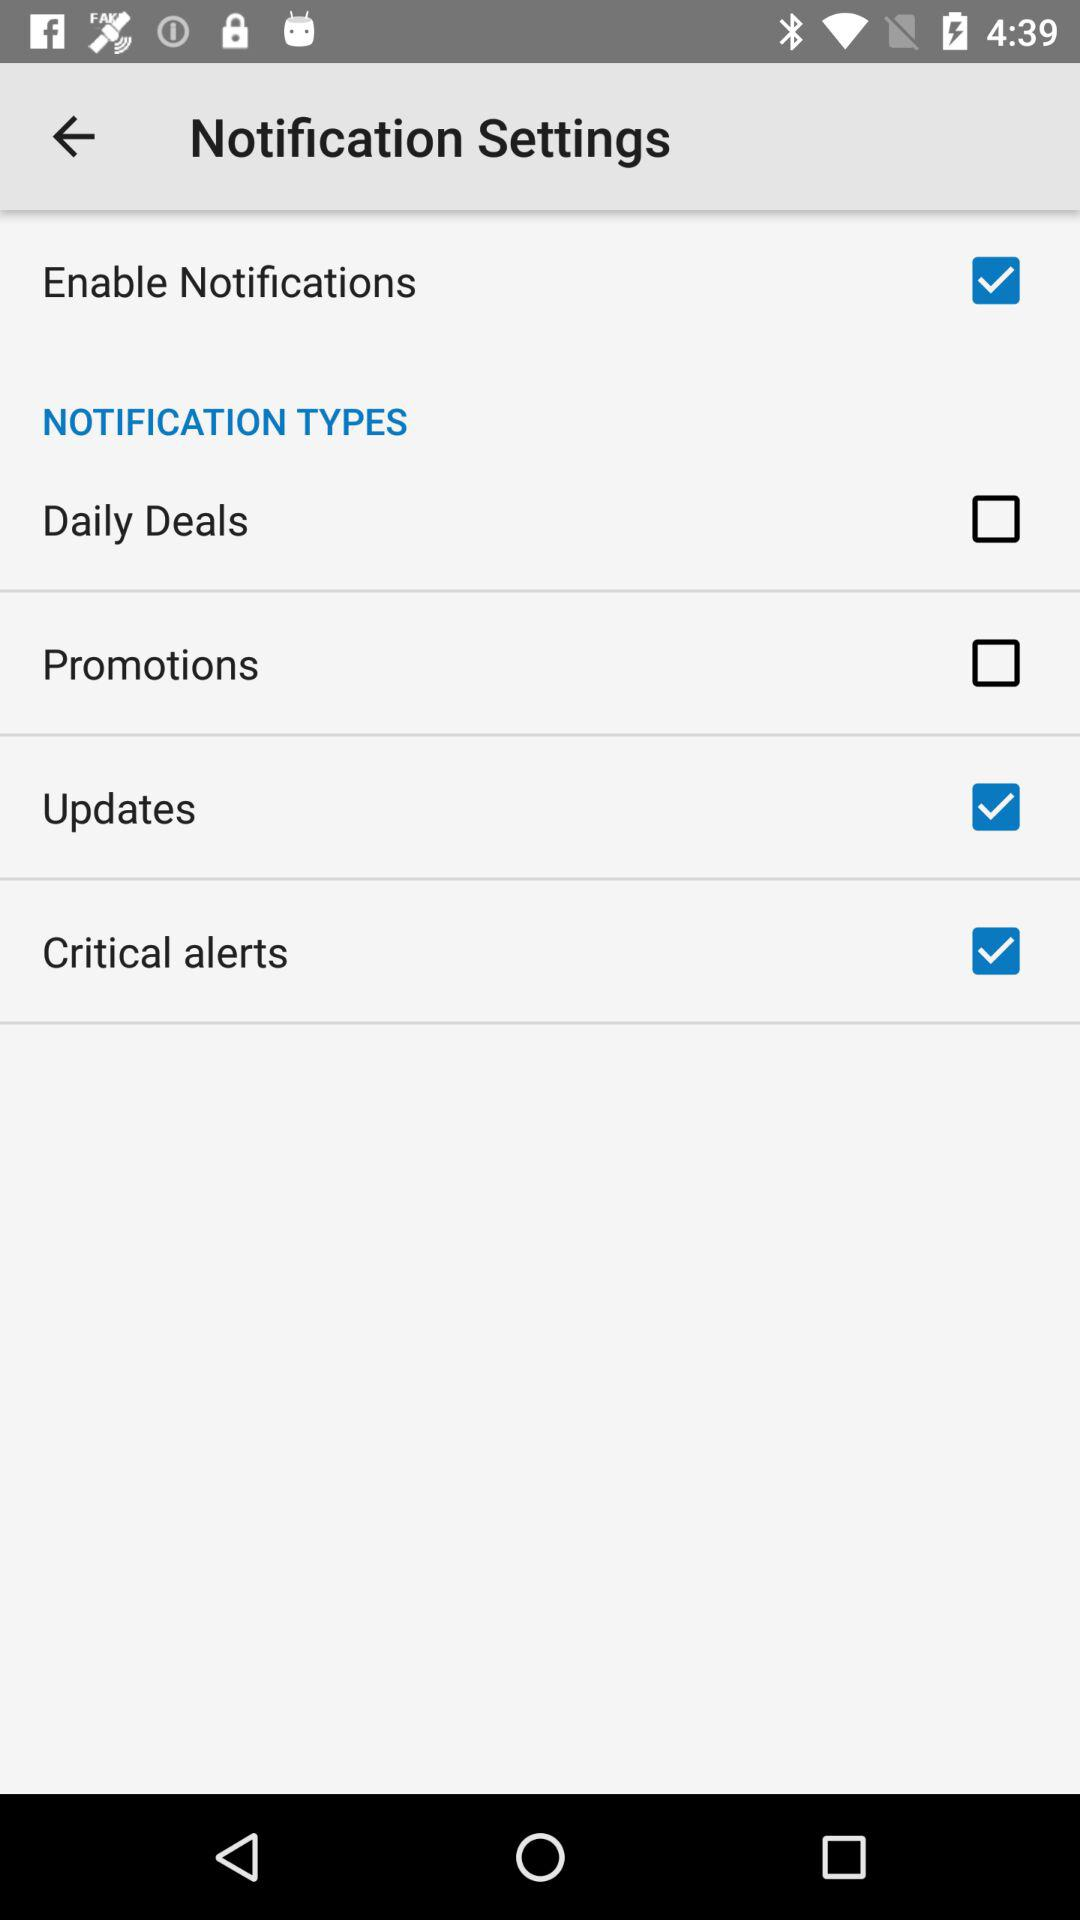What is the status of "Enable Notifications"? The status of "Enable Notifications" is "on". 